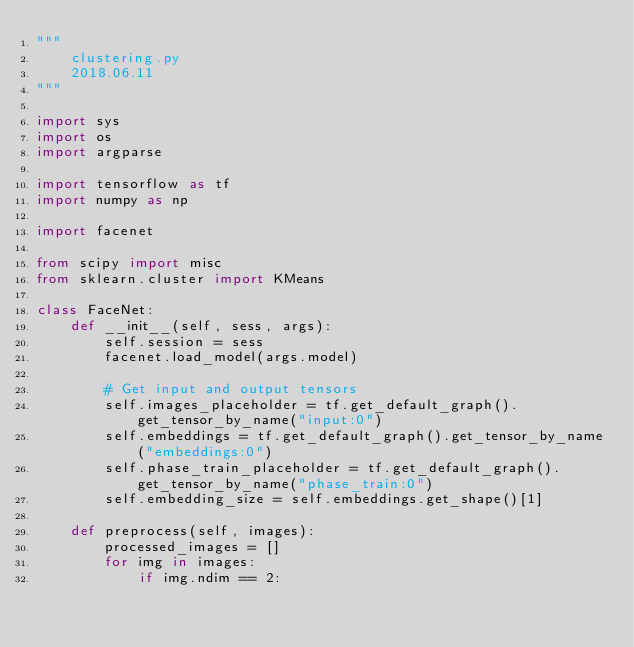<code> <loc_0><loc_0><loc_500><loc_500><_Python_>"""
    clustering.py
    2018.06.11
"""

import sys
import os
import argparse

import tensorflow as tf
import numpy as np

import facenet

from scipy import misc
from sklearn.cluster import KMeans

class FaceNet:
    def __init__(self, sess, args):
        self.session = sess
        facenet.load_model(args.model)

        # Get input and output tensors
        self.images_placeholder = tf.get_default_graph().get_tensor_by_name("input:0")
        self.embeddings = tf.get_default_graph().get_tensor_by_name("embeddings:0")
        self.phase_train_placeholder = tf.get_default_graph().get_tensor_by_name("phase_train:0")
        self.embedding_size = self.embeddings.get_shape()[1]

    def preprocess(self, images):
        processed_images = []
        for img in images:
            if img.ndim == 2:</code> 